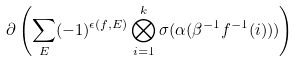Convert formula to latex. <formula><loc_0><loc_0><loc_500><loc_500>\partial \left ( \sum _ { E } ( - 1 ) ^ { \epsilon ( f , E ) } \bigotimes _ { i = 1 } ^ { k } \sigma ( \alpha ( \beta ^ { - 1 } f ^ { - 1 } ( i ) ) ) \right )</formula> 